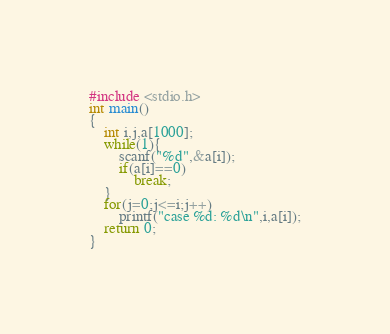Convert code to text. <code><loc_0><loc_0><loc_500><loc_500><_C_>#include <stdio.h>
int main()
{
	int i,j,a[1000];
	while(1){
		scanf("%d",&a[i]);
		if(a[i]==0)
			break;
	}
	for(j=0;j<=i;j++)
		printf("case %d: %d\n",i,a[i]);
	return 0;
}</code> 